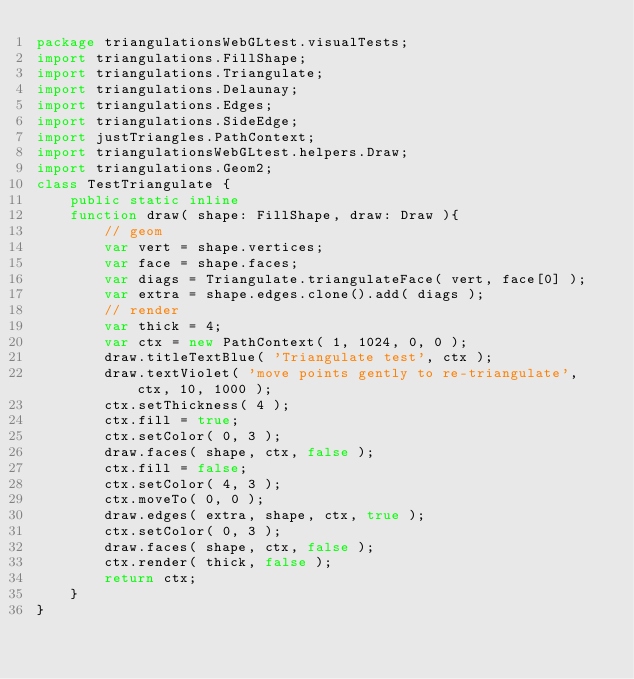Convert code to text. <code><loc_0><loc_0><loc_500><loc_500><_Haxe_>package triangulationsWebGLtest.visualTests;
import triangulations.FillShape;
import triangulations.Triangulate;
import triangulations.Delaunay;
import triangulations.Edges;
import triangulations.SideEdge;
import justTriangles.PathContext;
import triangulationsWebGLtest.helpers.Draw;
import triangulations.Geom2;
class TestTriangulate {
    public static inline 
    function draw( shape: FillShape, draw: Draw ){
        // geom
        var vert = shape.vertices;
        var face = shape.faces;
        var diags = Triangulate.triangulateFace( vert, face[0] );
        var extra = shape.edges.clone().add( diags );
        // render
        var thick = 4;
        var ctx = new PathContext( 1, 1024, 0, 0 );
        draw.titleTextBlue( 'Triangulate test', ctx );
        draw.textViolet( 'move points gently to re-triangulate', ctx, 10, 1000 );
        ctx.setThickness( 4 );
        ctx.fill = true;
        ctx.setColor( 0, 3 );
        draw.faces( shape, ctx, false );
        ctx.fill = false;
        ctx.setColor( 4, 3 );
        ctx.moveTo( 0, 0 );
        draw.edges( extra, shape, ctx, true );
        ctx.setColor( 0, 3 );
        draw.faces( shape, ctx, false );
        ctx.render( thick, false );
        return ctx;
    }
}
</code> 